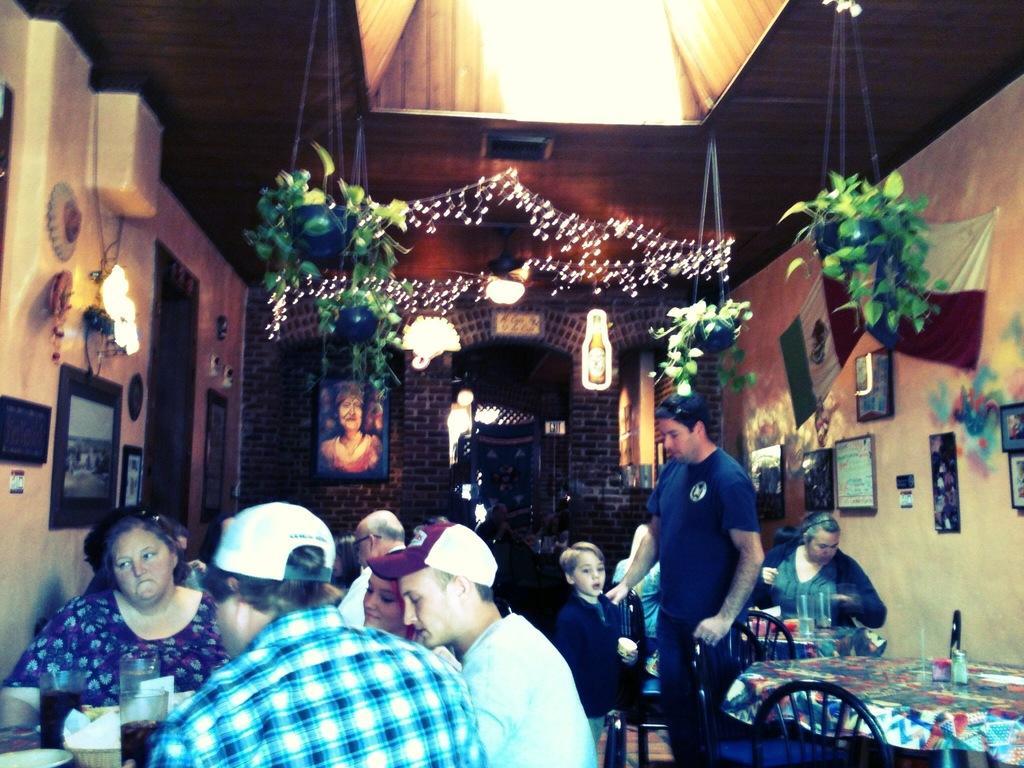Could you give a brief overview of what you see in this image? In this image in the center there are group of persons sitting and there are persons standing. On the top there are plants hanging in the pots and on the right side of the wall there are frames. On the left side there are frames and there are objects on the wall hanging. In the background there is a frame on the wall. On the right side there is a table and there are two empty chairs. 